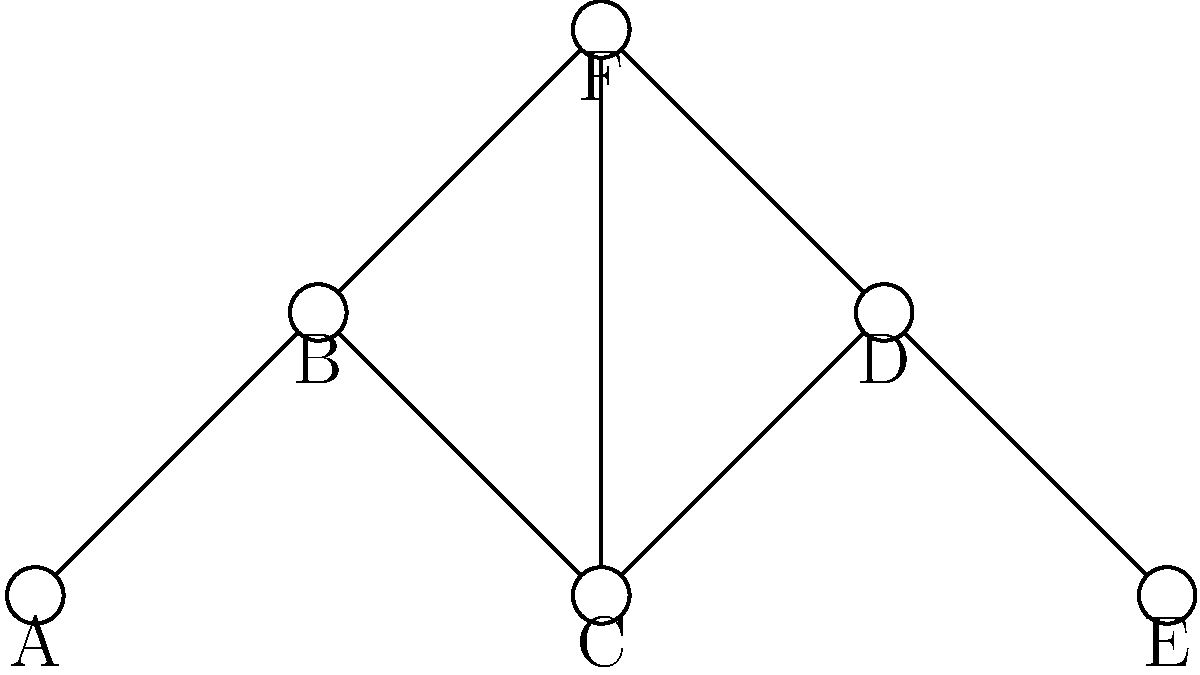Given the network topology shown above, which node has the highest betweenness centrality and is therefore the most critical for maintaining network connectivity? To determine the node with the highest betweenness centrality, we need to follow these steps:

1. Understand betweenness centrality: It measures the extent to which a node lies on the shortest paths between other nodes in the network.

2. Identify all shortest paths:
   - A to E: A-B-C-D-E
   - A to F: A-B-F
   - B to E: B-C-D-E
   - C to F: C-F
   - D to F: D-F
   - E to F: E-D-F

3. Count the number of shortest paths each node appears in:
   A: 2
   B: 3
   C: 3
   D: 3
   E: 1
   F: 5

4. Analyze the results:
   Node C appears in 3 shortest paths and is centrally located. It connects the left and right sides of the network and is part of the path from A to E.

5. Consider network impact:
   Removing node C would significantly disrupt the network, forcing traffic to route through F, potentially causing congestion and increasing vulnerability.

Therefore, node C has the highest betweenness centrality and is the most critical for maintaining network connectivity.
Answer: C 